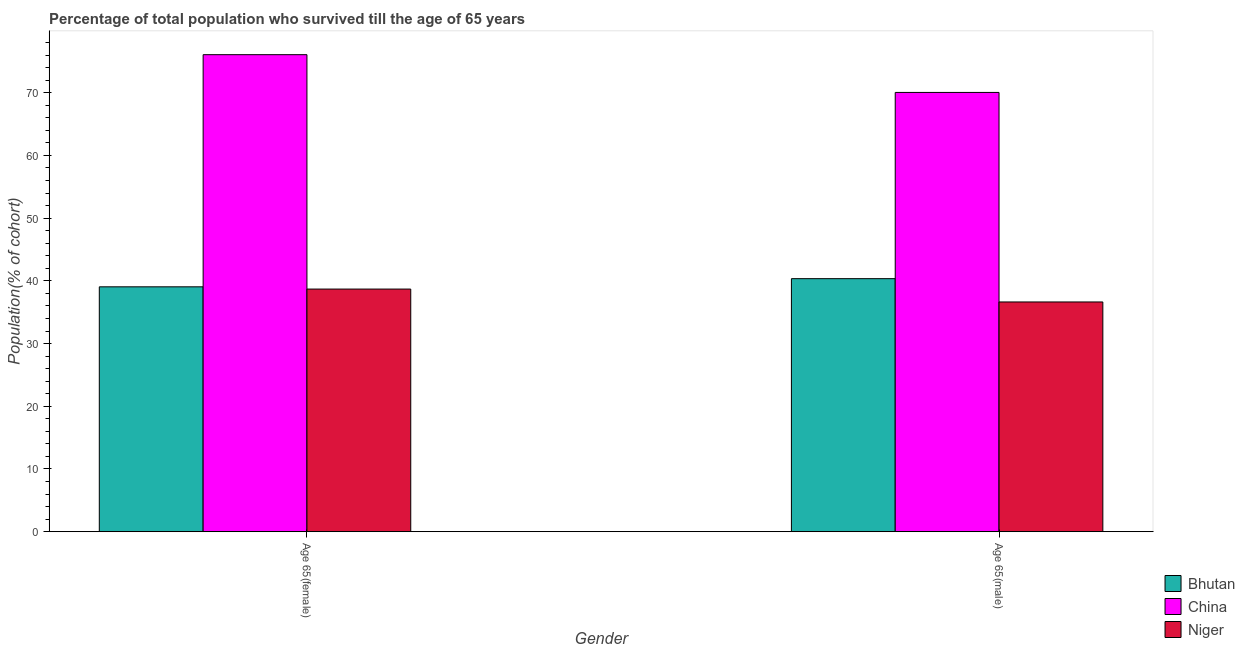How many different coloured bars are there?
Offer a very short reply. 3. How many groups of bars are there?
Ensure brevity in your answer.  2. How many bars are there on the 1st tick from the left?
Keep it short and to the point. 3. How many bars are there on the 1st tick from the right?
Offer a very short reply. 3. What is the label of the 1st group of bars from the left?
Offer a terse response. Age 65(female). What is the percentage of male population who survived till age of 65 in China?
Provide a succinct answer. 70.05. Across all countries, what is the maximum percentage of male population who survived till age of 65?
Offer a very short reply. 70.05. Across all countries, what is the minimum percentage of female population who survived till age of 65?
Your answer should be very brief. 38.69. In which country was the percentage of male population who survived till age of 65 maximum?
Offer a terse response. China. In which country was the percentage of female population who survived till age of 65 minimum?
Ensure brevity in your answer.  Niger. What is the total percentage of male population who survived till age of 65 in the graph?
Offer a very short reply. 147.04. What is the difference between the percentage of female population who survived till age of 65 in Bhutan and that in Niger?
Provide a short and direct response. 0.36. What is the difference between the percentage of male population who survived till age of 65 in Niger and the percentage of female population who survived till age of 65 in Bhutan?
Make the answer very short. -2.41. What is the average percentage of male population who survived till age of 65 per country?
Your answer should be very brief. 49.01. What is the difference between the percentage of male population who survived till age of 65 and percentage of female population who survived till age of 65 in Bhutan?
Ensure brevity in your answer.  1.3. In how many countries, is the percentage of male population who survived till age of 65 greater than 44 %?
Offer a very short reply. 1. What is the ratio of the percentage of female population who survived till age of 65 in Bhutan to that in China?
Provide a succinct answer. 0.51. Is the percentage of female population who survived till age of 65 in China less than that in Bhutan?
Offer a terse response. No. What does the 2nd bar from the left in Age 65(male) represents?
Make the answer very short. China. What does the 2nd bar from the right in Age 65(male) represents?
Your answer should be compact. China. How many countries are there in the graph?
Make the answer very short. 3. Are the values on the major ticks of Y-axis written in scientific E-notation?
Your answer should be compact. No. Where does the legend appear in the graph?
Your answer should be very brief. Bottom right. What is the title of the graph?
Ensure brevity in your answer.  Percentage of total population who survived till the age of 65 years. Does "High income: OECD" appear as one of the legend labels in the graph?
Provide a short and direct response. No. What is the label or title of the Y-axis?
Provide a succinct answer. Population(% of cohort). What is the Population(% of cohort) of Bhutan in Age 65(female)?
Your answer should be very brief. 39.05. What is the Population(% of cohort) in China in Age 65(female)?
Provide a succinct answer. 76.07. What is the Population(% of cohort) in Niger in Age 65(female)?
Your response must be concise. 38.69. What is the Population(% of cohort) in Bhutan in Age 65(male)?
Offer a very short reply. 40.35. What is the Population(% of cohort) in China in Age 65(male)?
Make the answer very short. 70.05. What is the Population(% of cohort) in Niger in Age 65(male)?
Ensure brevity in your answer.  36.64. Across all Gender, what is the maximum Population(% of cohort) in Bhutan?
Make the answer very short. 40.35. Across all Gender, what is the maximum Population(% of cohort) in China?
Offer a terse response. 76.07. Across all Gender, what is the maximum Population(% of cohort) in Niger?
Ensure brevity in your answer.  38.69. Across all Gender, what is the minimum Population(% of cohort) in Bhutan?
Ensure brevity in your answer.  39.05. Across all Gender, what is the minimum Population(% of cohort) in China?
Make the answer very short. 70.05. Across all Gender, what is the minimum Population(% of cohort) in Niger?
Keep it short and to the point. 36.64. What is the total Population(% of cohort) in Bhutan in the graph?
Offer a very short reply. 79.4. What is the total Population(% of cohort) in China in the graph?
Your answer should be compact. 146.12. What is the total Population(% of cohort) in Niger in the graph?
Make the answer very short. 75.33. What is the difference between the Population(% of cohort) of Bhutan in Age 65(female) and that in Age 65(male)?
Make the answer very short. -1.3. What is the difference between the Population(% of cohort) of China in Age 65(female) and that in Age 65(male)?
Offer a terse response. 6.02. What is the difference between the Population(% of cohort) in Niger in Age 65(female) and that in Age 65(male)?
Offer a terse response. 2.06. What is the difference between the Population(% of cohort) in Bhutan in Age 65(female) and the Population(% of cohort) in China in Age 65(male)?
Offer a very short reply. -31. What is the difference between the Population(% of cohort) of Bhutan in Age 65(female) and the Population(% of cohort) of Niger in Age 65(male)?
Your answer should be compact. 2.41. What is the difference between the Population(% of cohort) of China in Age 65(female) and the Population(% of cohort) of Niger in Age 65(male)?
Your answer should be very brief. 39.43. What is the average Population(% of cohort) of Bhutan per Gender?
Keep it short and to the point. 39.7. What is the average Population(% of cohort) of China per Gender?
Ensure brevity in your answer.  73.06. What is the average Population(% of cohort) in Niger per Gender?
Your response must be concise. 37.66. What is the difference between the Population(% of cohort) in Bhutan and Population(% of cohort) in China in Age 65(female)?
Provide a short and direct response. -37.02. What is the difference between the Population(% of cohort) of Bhutan and Population(% of cohort) of Niger in Age 65(female)?
Your answer should be very brief. 0.36. What is the difference between the Population(% of cohort) of China and Population(% of cohort) of Niger in Age 65(female)?
Provide a succinct answer. 37.38. What is the difference between the Population(% of cohort) in Bhutan and Population(% of cohort) in China in Age 65(male)?
Your answer should be very brief. -29.7. What is the difference between the Population(% of cohort) in Bhutan and Population(% of cohort) in Niger in Age 65(male)?
Your response must be concise. 3.72. What is the difference between the Population(% of cohort) of China and Population(% of cohort) of Niger in Age 65(male)?
Provide a short and direct response. 33.41. What is the ratio of the Population(% of cohort) in China in Age 65(female) to that in Age 65(male)?
Keep it short and to the point. 1.09. What is the ratio of the Population(% of cohort) of Niger in Age 65(female) to that in Age 65(male)?
Provide a succinct answer. 1.06. What is the difference between the highest and the second highest Population(% of cohort) of Bhutan?
Ensure brevity in your answer.  1.3. What is the difference between the highest and the second highest Population(% of cohort) of China?
Provide a short and direct response. 6.02. What is the difference between the highest and the second highest Population(% of cohort) of Niger?
Make the answer very short. 2.06. What is the difference between the highest and the lowest Population(% of cohort) in Bhutan?
Make the answer very short. 1.3. What is the difference between the highest and the lowest Population(% of cohort) in China?
Your answer should be compact. 6.02. What is the difference between the highest and the lowest Population(% of cohort) in Niger?
Your response must be concise. 2.06. 